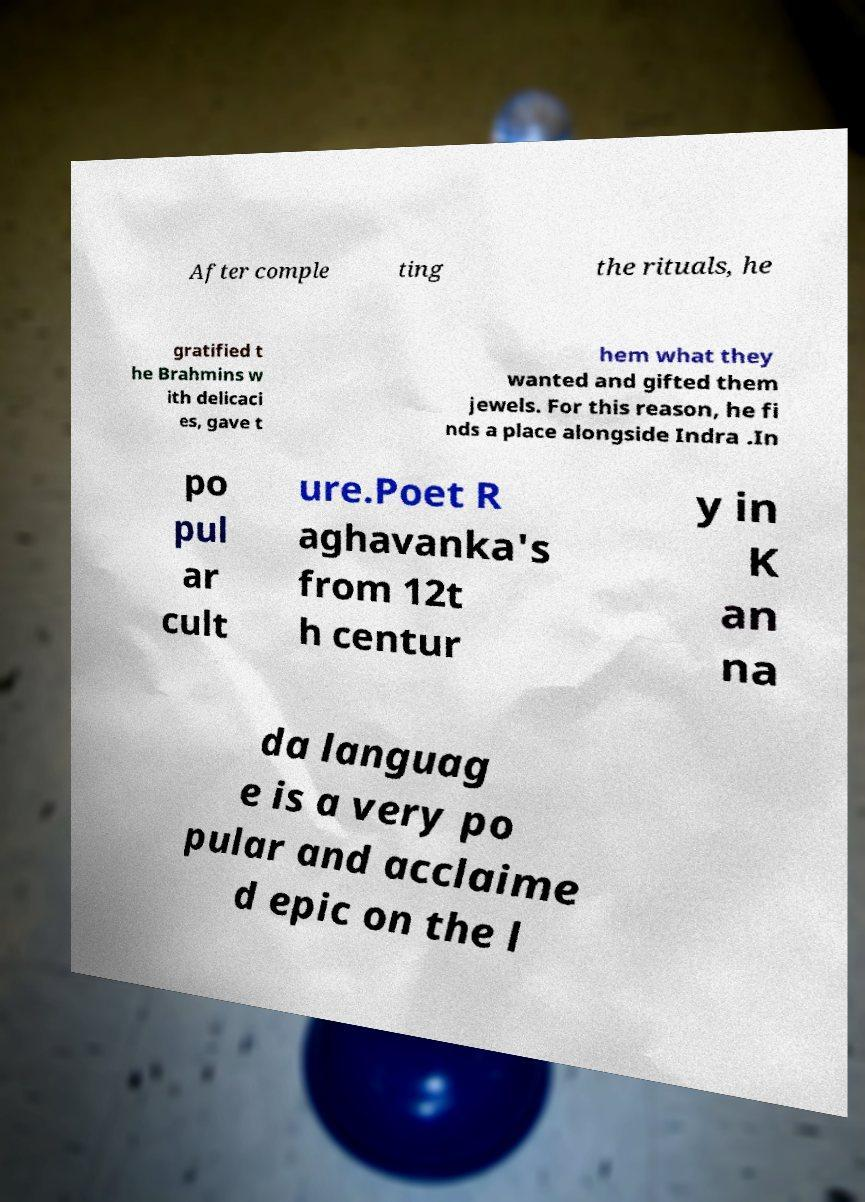What messages or text are displayed in this image? I need them in a readable, typed format. After comple ting the rituals, he gratified t he Brahmins w ith delicaci es, gave t hem what they wanted and gifted them jewels. For this reason, he fi nds a place alongside Indra .In po pul ar cult ure.Poet R aghavanka's from 12t h centur y in K an na da languag e is a very po pular and acclaime d epic on the l 